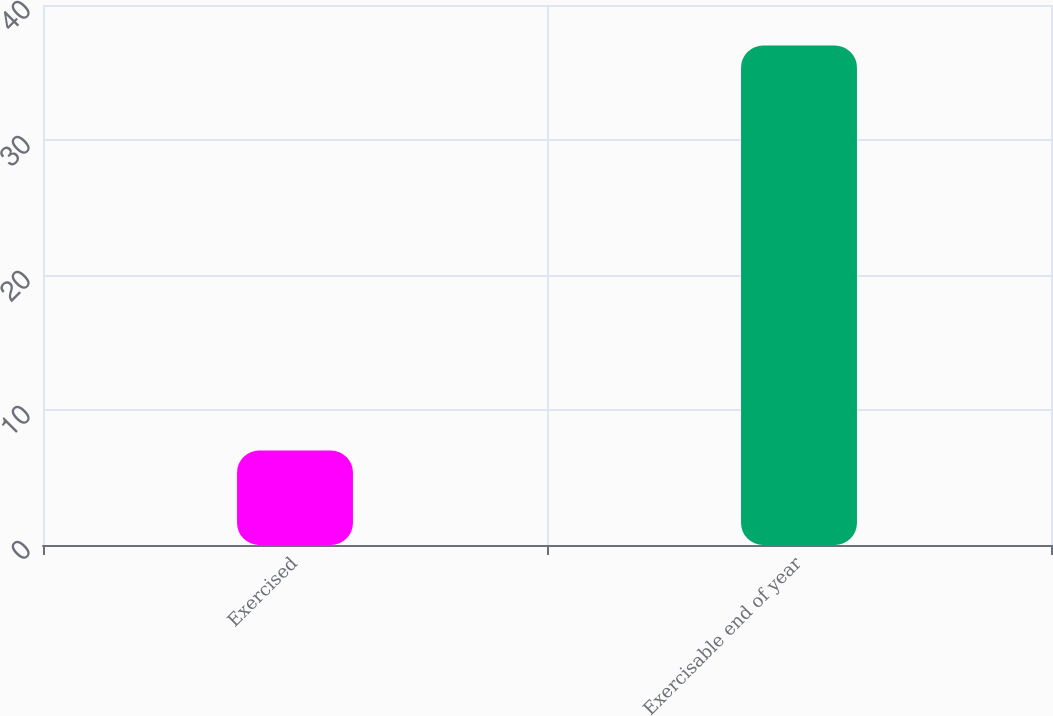Convert chart to OTSL. <chart><loc_0><loc_0><loc_500><loc_500><bar_chart><fcel>Exercised<fcel>Exercisable end of year<nl><fcel>7<fcel>37<nl></chart> 